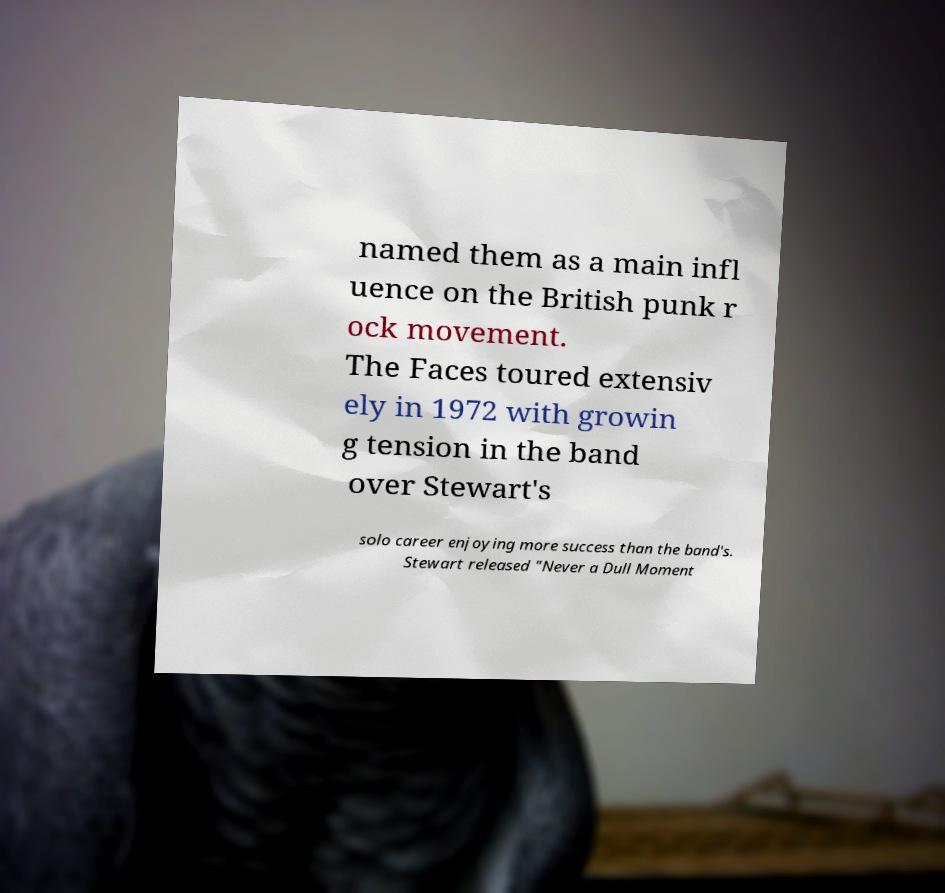Can you read and provide the text displayed in the image?This photo seems to have some interesting text. Can you extract and type it out for me? named them as a main infl uence on the British punk r ock movement. The Faces toured extensiv ely in 1972 with growin g tension in the band over Stewart's solo career enjoying more success than the band's. Stewart released "Never a Dull Moment 